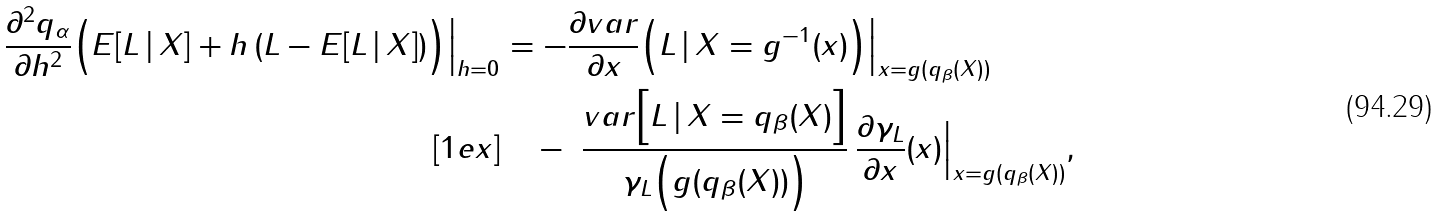Convert formula to latex. <formula><loc_0><loc_0><loc_500><loc_500>\frac { \partial ^ { 2 } q _ { \alpha } } { \partial h ^ { 2 } } \Big ( E [ L \, | \, X ] + h \, ( L - E [ L \, | \, X ] ) \Big ) \Big | _ { h = 0 } & = - \frac { \partial v a r } { \partial x } \Big ( L \, | \, X = g ^ { - 1 } ( x ) \Big ) \Big | _ { x = g ( q _ { \beta } ( X ) ) } \\ [ 1 e x ] & \quad - \ \frac { v a r \Big [ L \, | \, X = q _ { \beta } ( X ) \Big ] } { \gamma _ { L } \Big ( g ( q _ { \beta } ( X ) ) \Big ) } \, \frac { \partial \gamma _ { L } } { \partial x } ( x ) \Big | _ { x = g ( q _ { \beta } ( X ) ) } ,</formula> 